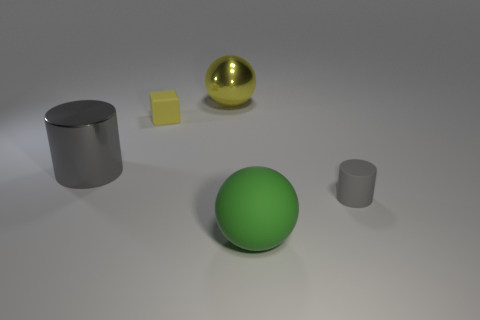Add 3 large purple spheres. How many objects exist? 8 Subtract all cylinders. How many objects are left? 3 Subtract all cylinders. Subtract all yellow matte cubes. How many objects are left? 2 Add 3 large gray cylinders. How many large gray cylinders are left? 4 Add 1 small rubber cubes. How many small rubber cubes exist? 2 Subtract 0 red spheres. How many objects are left? 5 